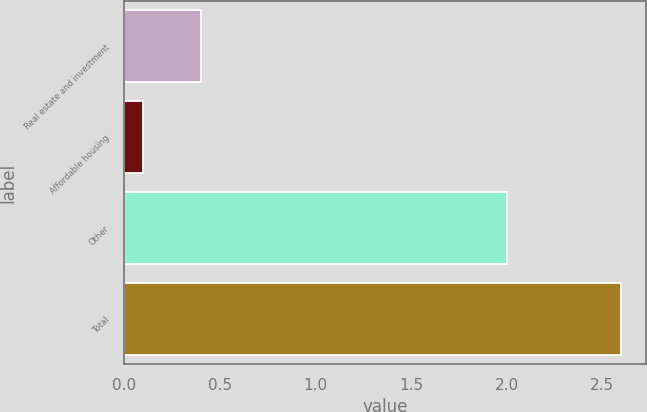Convert chart. <chart><loc_0><loc_0><loc_500><loc_500><bar_chart><fcel>Real estate and investment<fcel>Affordable housing<fcel>Other<fcel>Total<nl><fcel>0.4<fcel>0.1<fcel>2<fcel>2.6<nl></chart> 